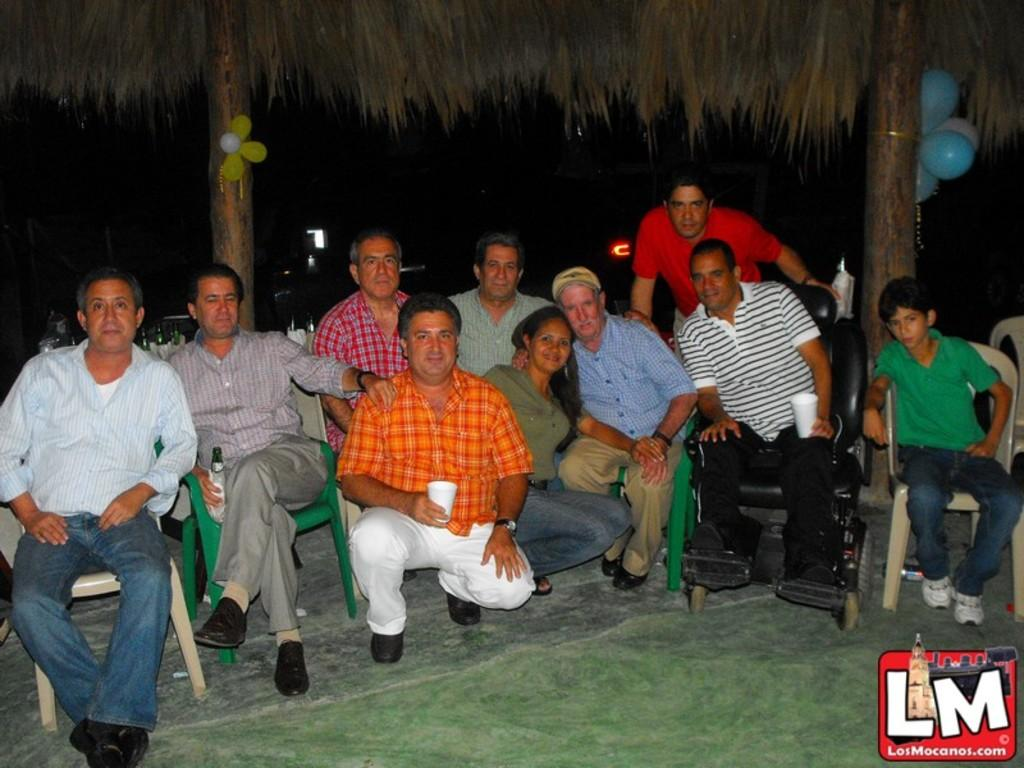What are the people in the image doing? The persons in the image are sitting on chairs in the foreground. Where are the chairs located? The chairs are on the ground. What can be seen in the background of the image? There are two pillars visible in the image. What is attached to the pillars? Balloons are attached to the pillars. What type of sheep can be seen grazing on the salt in the image? There are no sheep or salt present in the image. How many beans are visible on the chairs in the image? There are no beans visible on the chairs in the image. 